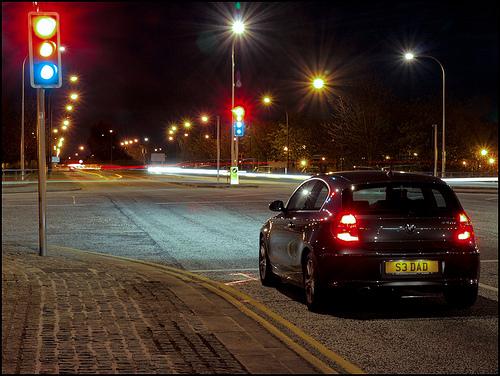Is the car moving?
Answer briefly. No. What is the license plate number?
Short answer required. Sad. Are any cars stopped at the intersection?
Quick response, please. Yes. Is it daytime?
Write a very short answer. No. 